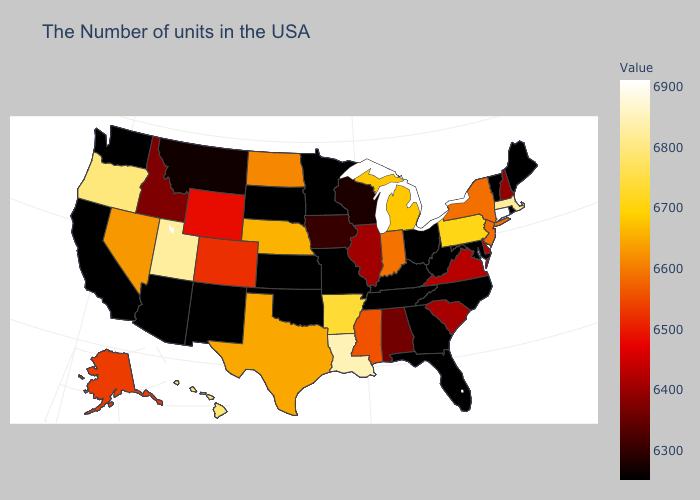Which states have the highest value in the USA?
Be succinct. Connecticut. Among the states that border Colorado , which have the highest value?
Keep it brief. Utah. Does the map have missing data?
Concise answer only. No. Which states have the lowest value in the USA?
Answer briefly. Maine, Rhode Island, Vermont, Maryland, North Carolina, West Virginia, Ohio, Florida, Georgia, Kentucky, Tennessee, Missouri, Minnesota, Kansas, Oklahoma, South Dakota, New Mexico, Arizona, California, Washington. Among the states that border Arizona , does California have the highest value?
Quick response, please. No. 